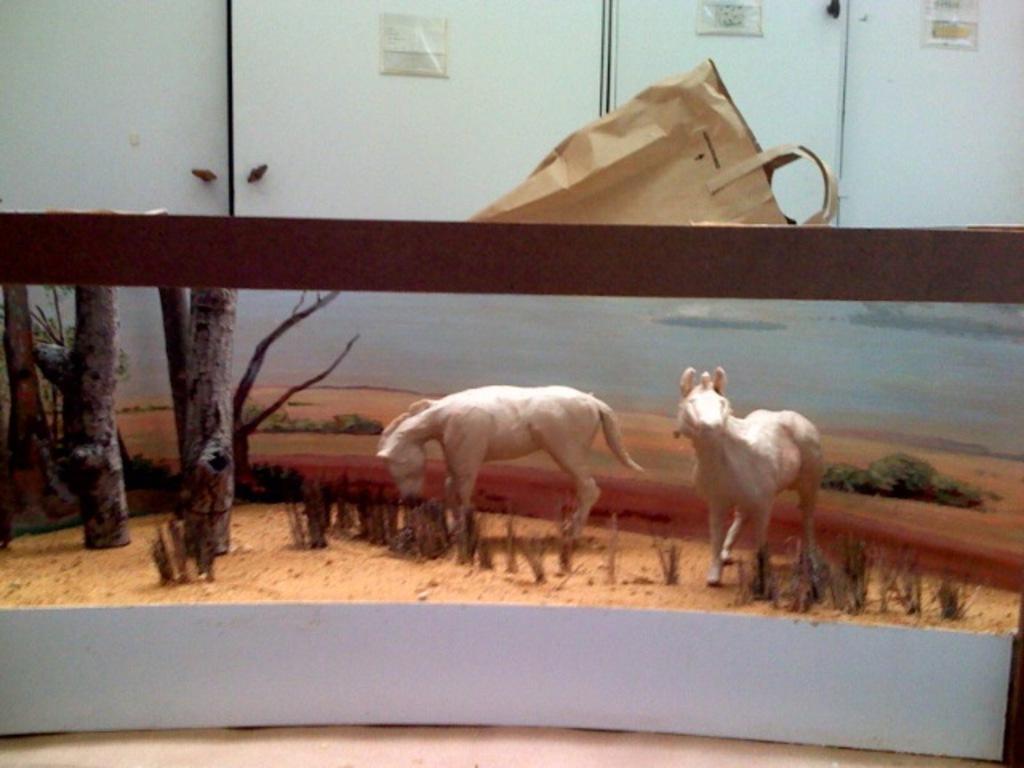In one or two sentences, can you explain what this image depicts? This image is taken indoors. At the bottom of the image there is a floor. At the top of the image there are few cupboards and there is a paper bag. In the middle of the image there are two toy animals and there are few toy trees. 